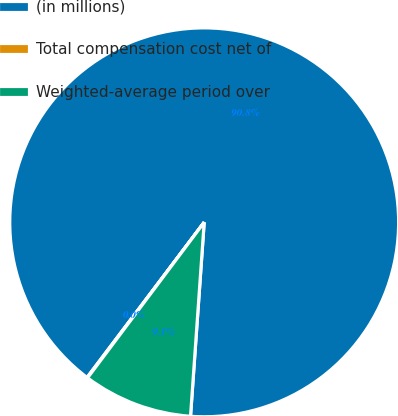<chart> <loc_0><loc_0><loc_500><loc_500><pie_chart><fcel>(in millions)<fcel>Total compensation cost net of<fcel>Weighted-average period over<nl><fcel>90.83%<fcel>0.05%<fcel>9.12%<nl></chart> 